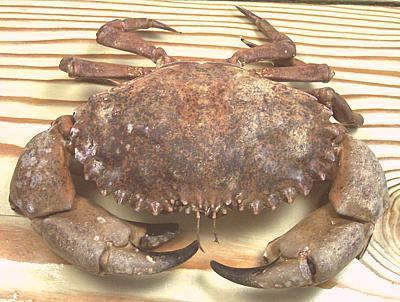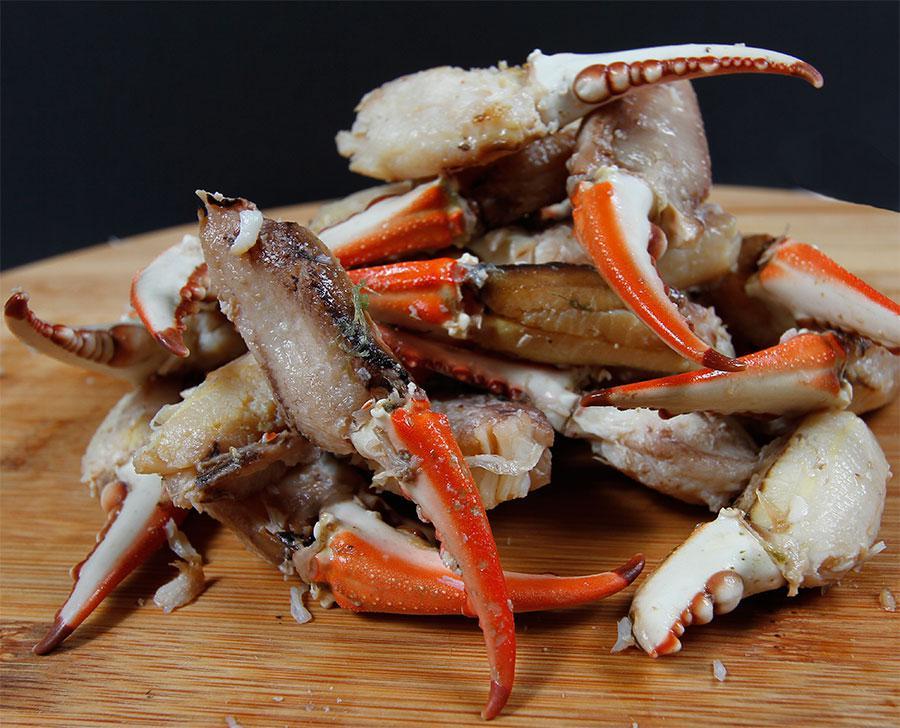The first image is the image on the left, the second image is the image on the right. Examine the images to the left and right. Is the description "There are two whole crabs." accurate? Answer yes or no. No. 